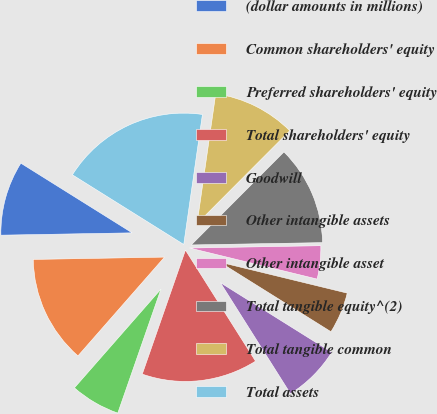Convert chart to OTSL. <chart><loc_0><loc_0><loc_500><loc_500><pie_chart><fcel>(dollar amounts in millions)<fcel>Common shareholders' equity<fcel>Preferred shareholders' equity<fcel>Total shareholders' equity<fcel>Goodwill<fcel>Other intangible assets<fcel>Other intangible asset<fcel>Total tangible equity^(2)<fcel>Total tangible common<fcel>Total assets<nl><fcel>9.18%<fcel>13.26%<fcel>6.12%<fcel>14.29%<fcel>7.14%<fcel>5.1%<fcel>4.08%<fcel>12.24%<fcel>10.2%<fcel>18.37%<nl></chart> 